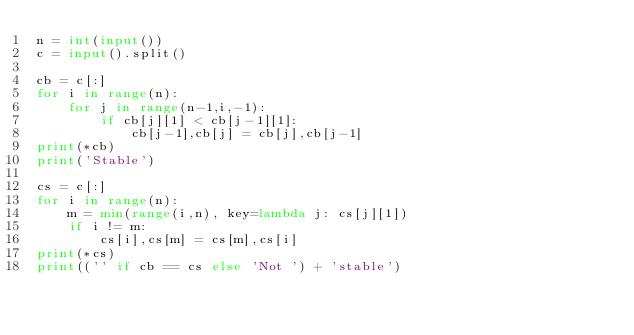Convert code to text. <code><loc_0><loc_0><loc_500><loc_500><_Python_>n = int(input())
c = input().split()

cb = c[:]
for i in range(n):
	for j in range(n-1,i,-1):
		if cb[j][1] < cb[j-1][1]:
			cb[j-1],cb[j] = cb[j],cb[j-1]
print(*cb)
print('Stable')

cs = c[:]
for i in range(n):
	m = min(range(i,n), key=lambda j: cs[j][1])
	if i != m:
		cs[i],cs[m] = cs[m],cs[i]
print(*cs)
print(('' if cb == cs else 'Not ') + 'stable')
</code> 